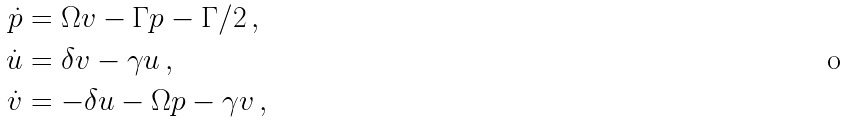<formula> <loc_0><loc_0><loc_500><loc_500>\dot { p } & = \Omega v - \Gamma p - \Gamma / 2 \, , \\ \dot { u } & = \delta v - \gamma u \, , \, \\ \dot { v } & = - \delta u - \Omega p - \gamma v \, ,</formula> 